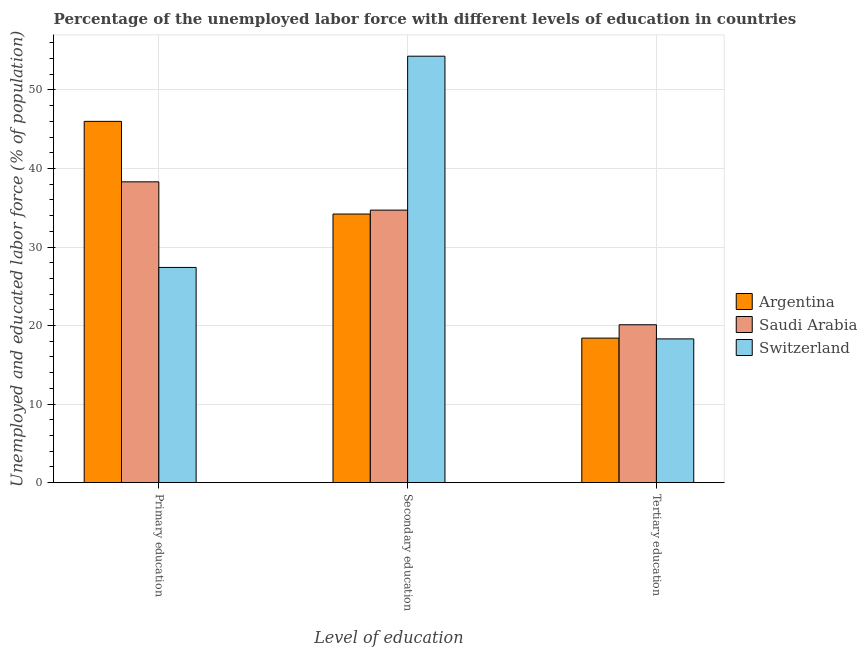How many different coloured bars are there?
Your answer should be very brief. 3. How many groups of bars are there?
Give a very brief answer. 3. What is the label of the 3rd group of bars from the left?
Give a very brief answer. Tertiary education. What is the percentage of labor force who received tertiary education in Saudi Arabia?
Provide a succinct answer. 20.1. Across all countries, what is the maximum percentage of labor force who received tertiary education?
Your answer should be compact. 20.1. Across all countries, what is the minimum percentage of labor force who received tertiary education?
Provide a succinct answer. 18.3. In which country was the percentage of labor force who received secondary education maximum?
Provide a short and direct response. Switzerland. What is the total percentage of labor force who received primary education in the graph?
Provide a succinct answer. 111.7. What is the difference between the percentage of labor force who received secondary education in Switzerland and that in Argentina?
Provide a short and direct response. 20.1. What is the difference between the percentage of labor force who received tertiary education in Argentina and the percentage of labor force who received secondary education in Saudi Arabia?
Provide a succinct answer. -16.3. What is the average percentage of labor force who received secondary education per country?
Ensure brevity in your answer.  41.07. What is the difference between the percentage of labor force who received secondary education and percentage of labor force who received primary education in Saudi Arabia?
Provide a succinct answer. -3.6. What is the ratio of the percentage of labor force who received secondary education in Saudi Arabia to that in Argentina?
Keep it short and to the point. 1.01. What is the difference between the highest and the second highest percentage of labor force who received secondary education?
Ensure brevity in your answer.  19.6. What is the difference between the highest and the lowest percentage of labor force who received tertiary education?
Offer a terse response. 1.8. In how many countries, is the percentage of labor force who received primary education greater than the average percentage of labor force who received primary education taken over all countries?
Provide a succinct answer. 2. Is the sum of the percentage of labor force who received primary education in Argentina and Saudi Arabia greater than the maximum percentage of labor force who received tertiary education across all countries?
Your answer should be very brief. Yes. What does the 3rd bar from the left in Primary education represents?
Your answer should be very brief. Switzerland. Is it the case that in every country, the sum of the percentage of labor force who received primary education and percentage of labor force who received secondary education is greater than the percentage of labor force who received tertiary education?
Make the answer very short. Yes. How many bars are there?
Keep it short and to the point. 9. Are all the bars in the graph horizontal?
Ensure brevity in your answer.  No. What is the difference between two consecutive major ticks on the Y-axis?
Provide a succinct answer. 10. Are the values on the major ticks of Y-axis written in scientific E-notation?
Give a very brief answer. No. How are the legend labels stacked?
Provide a short and direct response. Vertical. What is the title of the graph?
Offer a very short reply. Percentage of the unemployed labor force with different levels of education in countries. Does "Mexico" appear as one of the legend labels in the graph?
Ensure brevity in your answer.  No. What is the label or title of the X-axis?
Offer a very short reply. Level of education. What is the label or title of the Y-axis?
Keep it short and to the point. Unemployed and educated labor force (% of population). What is the Unemployed and educated labor force (% of population) of Argentina in Primary education?
Make the answer very short. 46. What is the Unemployed and educated labor force (% of population) in Saudi Arabia in Primary education?
Provide a short and direct response. 38.3. What is the Unemployed and educated labor force (% of population) in Switzerland in Primary education?
Your answer should be compact. 27.4. What is the Unemployed and educated labor force (% of population) of Argentina in Secondary education?
Make the answer very short. 34.2. What is the Unemployed and educated labor force (% of population) of Saudi Arabia in Secondary education?
Make the answer very short. 34.7. What is the Unemployed and educated labor force (% of population) of Switzerland in Secondary education?
Offer a terse response. 54.3. What is the Unemployed and educated labor force (% of population) in Argentina in Tertiary education?
Your answer should be compact. 18.4. What is the Unemployed and educated labor force (% of population) of Saudi Arabia in Tertiary education?
Provide a short and direct response. 20.1. What is the Unemployed and educated labor force (% of population) in Switzerland in Tertiary education?
Offer a very short reply. 18.3. Across all Level of education, what is the maximum Unemployed and educated labor force (% of population) in Saudi Arabia?
Offer a terse response. 38.3. Across all Level of education, what is the maximum Unemployed and educated labor force (% of population) of Switzerland?
Your answer should be very brief. 54.3. Across all Level of education, what is the minimum Unemployed and educated labor force (% of population) of Argentina?
Give a very brief answer. 18.4. Across all Level of education, what is the minimum Unemployed and educated labor force (% of population) in Saudi Arabia?
Provide a short and direct response. 20.1. Across all Level of education, what is the minimum Unemployed and educated labor force (% of population) in Switzerland?
Keep it short and to the point. 18.3. What is the total Unemployed and educated labor force (% of population) of Argentina in the graph?
Provide a succinct answer. 98.6. What is the total Unemployed and educated labor force (% of population) in Saudi Arabia in the graph?
Offer a very short reply. 93.1. What is the difference between the Unemployed and educated labor force (% of population) in Switzerland in Primary education and that in Secondary education?
Keep it short and to the point. -26.9. What is the difference between the Unemployed and educated labor force (% of population) of Argentina in Primary education and that in Tertiary education?
Keep it short and to the point. 27.6. What is the difference between the Unemployed and educated labor force (% of population) of Saudi Arabia in Primary education and that in Tertiary education?
Offer a very short reply. 18.2. What is the difference between the Unemployed and educated labor force (% of population) in Switzerland in Primary education and that in Tertiary education?
Offer a terse response. 9.1. What is the difference between the Unemployed and educated labor force (% of population) of Argentina in Primary education and the Unemployed and educated labor force (% of population) of Switzerland in Secondary education?
Offer a terse response. -8.3. What is the difference between the Unemployed and educated labor force (% of population) in Saudi Arabia in Primary education and the Unemployed and educated labor force (% of population) in Switzerland in Secondary education?
Your answer should be very brief. -16. What is the difference between the Unemployed and educated labor force (% of population) in Argentina in Primary education and the Unemployed and educated labor force (% of population) in Saudi Arabia in Tertiary education?
Offer a very short reply. 25.9. What is the difference between the Unemployed and educated labor force (% of population) in Argentina in Primary education and the Unemployed and educated labor force (% of population) in Switzerland in Tertiary education?
Make the answer very short. 27.7. What is the difference between the Unemployed and educated labor force (% of population) of Saudi Arabia in Primary education and the Unemployed and educated labor force (% of population) of Switzerland in Tertiary education?
Your response must be concise. 20. What is the difference between the Unemployed and educated labor force (% of population) of Argentina in Secondary education and the Unemployed and educated labor force (% of population) of Switzerland in Tertiary education?
Offer a terse response. 15.9. What is the difference between the Unemployed and educated labor force (% of population) of Saudi Arabia in Secondary education and the Unemployed and educated labor force (% of population) of Switzerland in Tertiary education?
Your answer should be compact. 16.4. What is the average Unemployed and educated labor force (% of population) of Argentina per Level of education?
Ensure brevity in your answer.  32.87. What is the average Unemployed and educated labor force (% of population) of Saudi Arabia per Level of education?
Your answer should be very brief. 31.03. What is the average Unemployed and educated labor force (% of population) of Switzerland per Level of education?
Make the answer very short. 33.33. What is the difference between the Unemployed and educated labor force (% of population) of Argentina and Unemployed and educated labor force (% of population) of Saudi Arabia in Primary education?
Ensure brevity in your answer.  7.7. What is the difference between the Unemployed and educated labor force (% of population) in Argentina and Unemployed and educated labor force (% of population) in Saudi Arabia in Secondary education?
Make the answer very short. -0.5. What is the difference between the Unemployed and educated labor force (% of population) of Argentina and Unemployed and educated labor force (% of population) of Switzerland in Secondary education?
Give a very brief answer. -20.1. What is the difference between the Unemployed and educated labor force (% of population) of Saudi Arabia and Unemployed and educated labor force (% of population) of Switzerland in Secondary education?
Give a very brief answer. -19.6. What is the difference between the Unemployed and educated labor force (% of population) of Argentina and Unemployed and educated labor force (% of population) of Switzerland in Tertiary education?
Offer a very short reply. 0.1. What is the difference between the Unemployed and educated labor force (% of population) of Saudi Arabia and Unemployed and educated labor force (% of population) of Switzerland in Tertiary education?
Your answer should be compact. 1.8. What is the ratio of the Unemployed and educated labor force (% of population) of Argentina in Primary education to that in Secondary education?
Offer a terse response. 1.34. What is the ratio of the Unemployed and educated labor force (% of population) in Saudi Arabia in Primary education to that in Secondary education?
Offer a terse response. 1.1. What is the ratio of the Unemployed and educated labor force (% of population) in Switzerland in Primary education to that in Secondary education?
Your response must be concise. 0.5. What is the ratio of the Unemployed and educated labor force (% of population) in Saudi Arabia in Primary education to that in Tertiary education?
Ensure brevity in your answer.  1.91. What is the ratio of the Unemployed and educated labor force (% of population) of Switzerland in Primary education to that in Tertiary education?
Offer a terse response. 1.5. What is the ratio of the Unemployed and educated labor force (% of population) of Argentina in Secondary education to that in Tertiary education?
Give a very brief answer. 1.86. What is the ratio of the Unemployed and educated labor force (% of population) in Saudi Arabia in Secondary education to that in Tertiary education?
Keep it short and to the point. 1.73. What is the ratio of the Unemployed and educated labor force (% of population) in Switzerland in Secondary education to that in Tertiary education?
Provide a short and direct response. 2.97. What is the difference between the highest and the second highest Unemployed and educated labor force (% of population) in Switzerland?
Offer a very short reply. 26.9. What is the difference between the highest and the lowest Unemployed and educated labor force (% of population) of Argentina?
Ensure brevity in your answer.  27.6. What is the difference between the highest and the lowest Unemployed and educated labor force (% of population) of Saudi Arabia?
Provide a succinct answer. 18.2. 